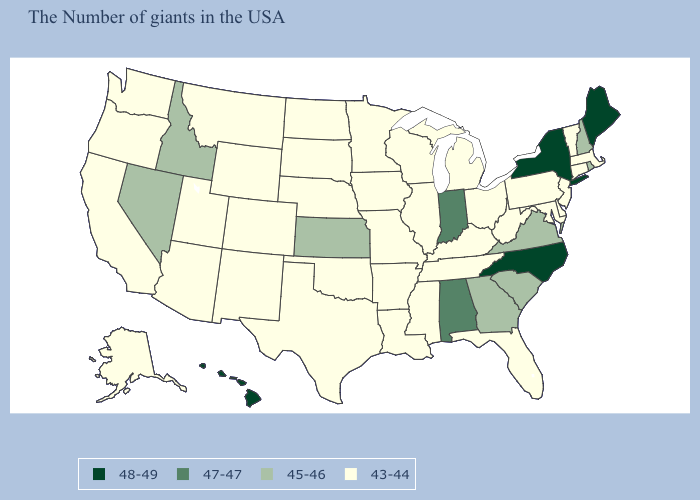What is the value of Nebraska?
Short answer required. 43-44. Does New Hampshire have a higher value than Hawaii?
Quick response, please. No. What is the value of Nebraska?
Short answer required. 43-44. What is the highest value in the USA?
Short answer required. 48-49. Does Alabama have the same value as Indiana?
Give a very brief answer. Yes. What is the value of Nevada?
Short answer required. 45-46. Does the map have missing data?
Be succinct. No. What is the value of North Carolina?
Answer briefly. 48-49. How many symbols are there in the legend?
Write a very short answer. 4. Name the states that have a value in the range 43-44?
Concise answer only. Massachusetts, Vermont, Connecticut, New Jersey, Delaware, Maryland, Pennsylvania, West Virginia, Ohio, Florida, Michigan, Kentucky, Tennessee, Wisconsin, Illinois, Mississippi, Louisiana, Missouri, Arkansas, Minnesota, Iowa, Nebraska, Oklahoma, Texas, South Dakota, North Dakota, Wyoming, Colorado, New Mexico, Utah, Montana, Arizona, California, Washington, Oregon, Alaska. Name the states that have a value in the range 48-49?
Concise answer only. Maine, New York, North Carolina, Hawaii. How many symbols are there in the legend?
Be succinct. 4. Which states hav the highest value in the Northeast?
Be succinct. Maine, New York. What is the highest value in the USA?
Concise answer only. 48-49. 